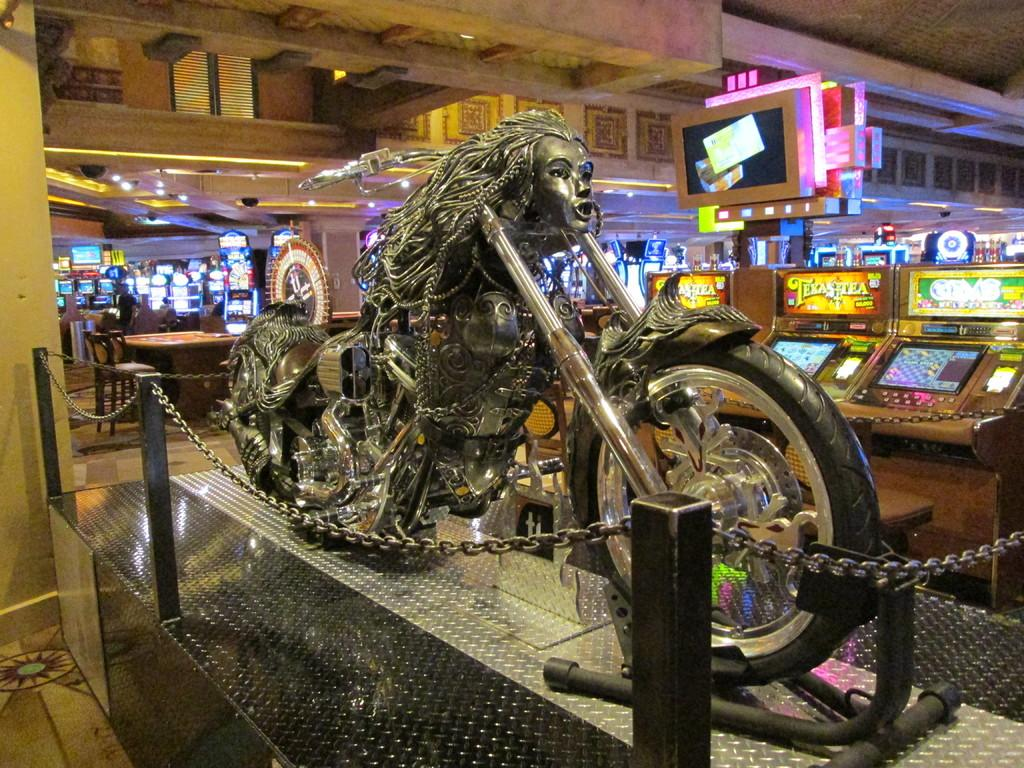What is the main subject of the image? There is a vehicle in the image. What type of enclosure surrounds the vehicle? There is a chain fencing around the vehicle. What other features can be seen in the image? There are many gaming zones visible in the image. What type of tree is growing in the middle of the vehicle in the image? There is no tree growing in the middle of the vehicle in the image. 